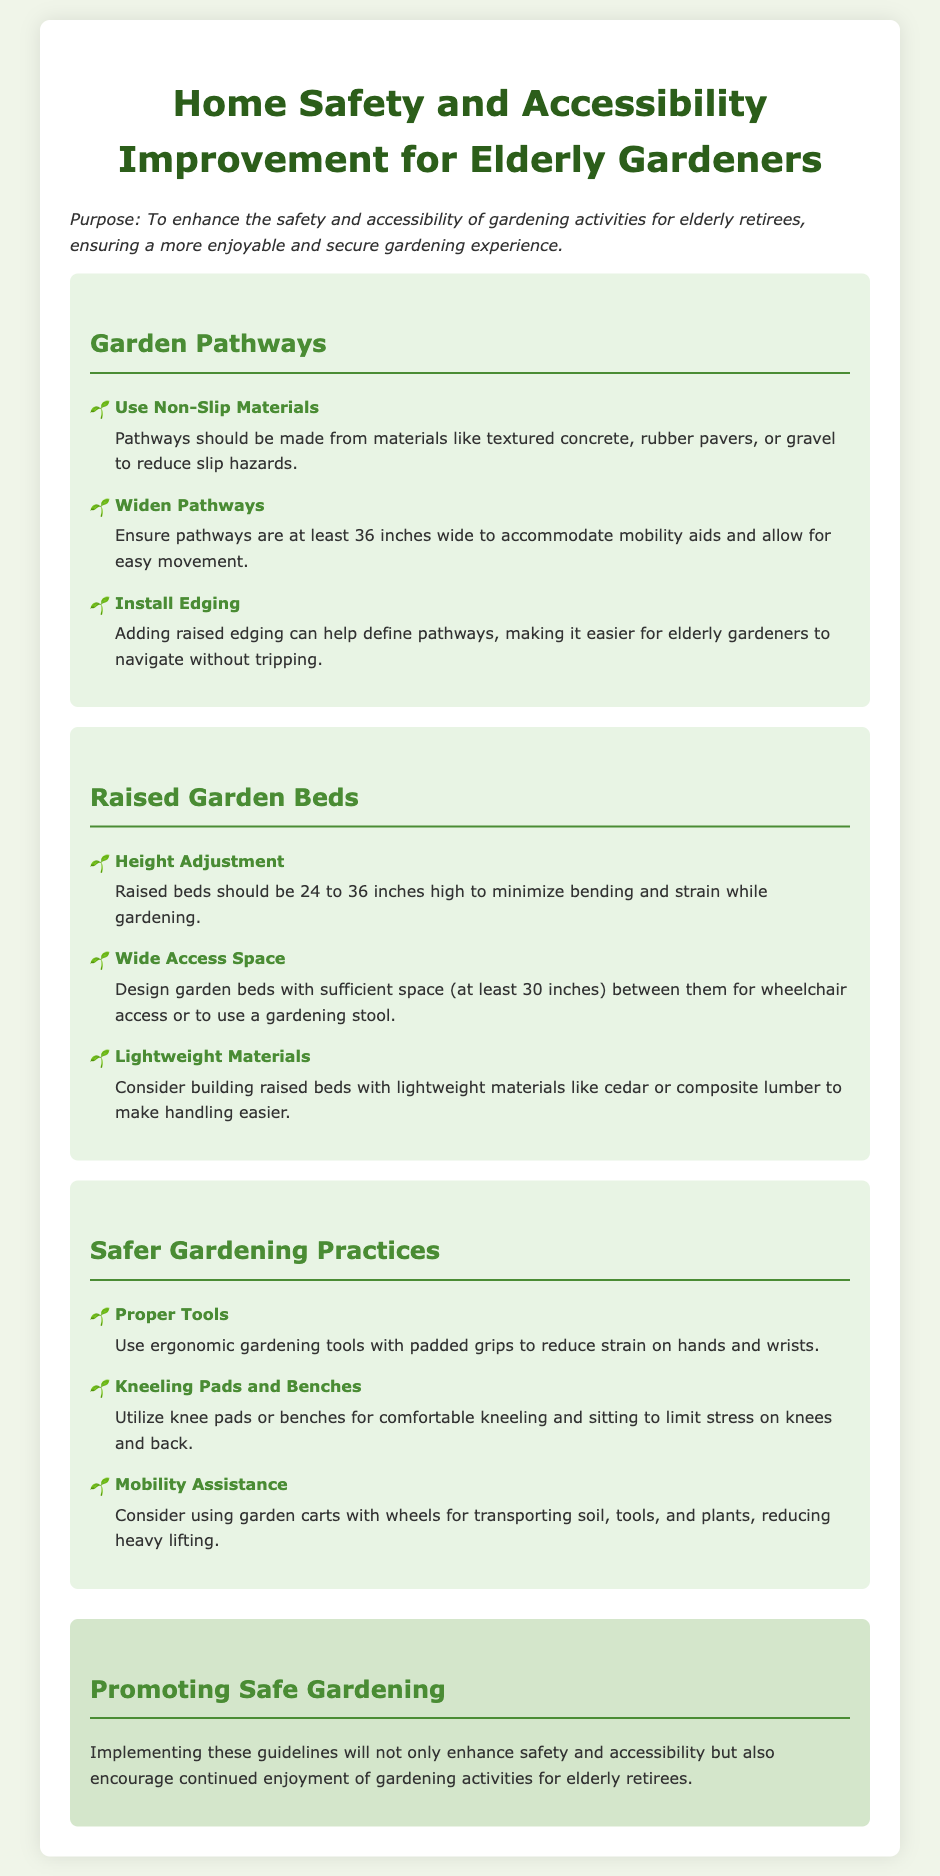What should be the minimum width of pathways? The document states that pathways should be at least 36 inches wide to accommodate mobility aids and allow for easy movement.
Answer: 36 inches What is the recommended height for raised garden beds? The recommended height for raised garden beds is 24 to 36 inches to minimize bending and strain while gardening.
Answer: 24 to 36 inches What type of materials should be used for pathways to reduce slip hazards? The document suggests using textured concrete, rubber pavers, or gravel for pathways to reduce slip hazards.
Answer: Textured concrete, rubber pavers, or gravel What can be utilized for comfortable kneeling and sitting? The document mentions using knee pads or benches for comfortable kneeling and sitting to limit stress on knees and back.
Answer: Knee pads or benches What is the purpose of installing edging for pathways? The purpose of adding raised edging is to help define pathways, making it easier for elderly gardeners to navigate without tripping.
Answer: To define pathways How wide should access spaces be between raised garden beds? The document specifies that access spaces should be at least 30 inches between raised garden beds for wheelchair access or to use a gardening stool.
Answer: 30 inches What type of gardening tools should be used to reduce strain on hands? The document recommends using ergonomic gardening tools with padded grips to reduce strain on hands and wrists.
Answer: Ergonomic gardening tools What is one piece of advice for reducing heavy lifting? The document advises considering using garden carts with wheels for transporting soil, tools, and plants to reduce heavy lifting.
Answer: Garden carts with wheels 